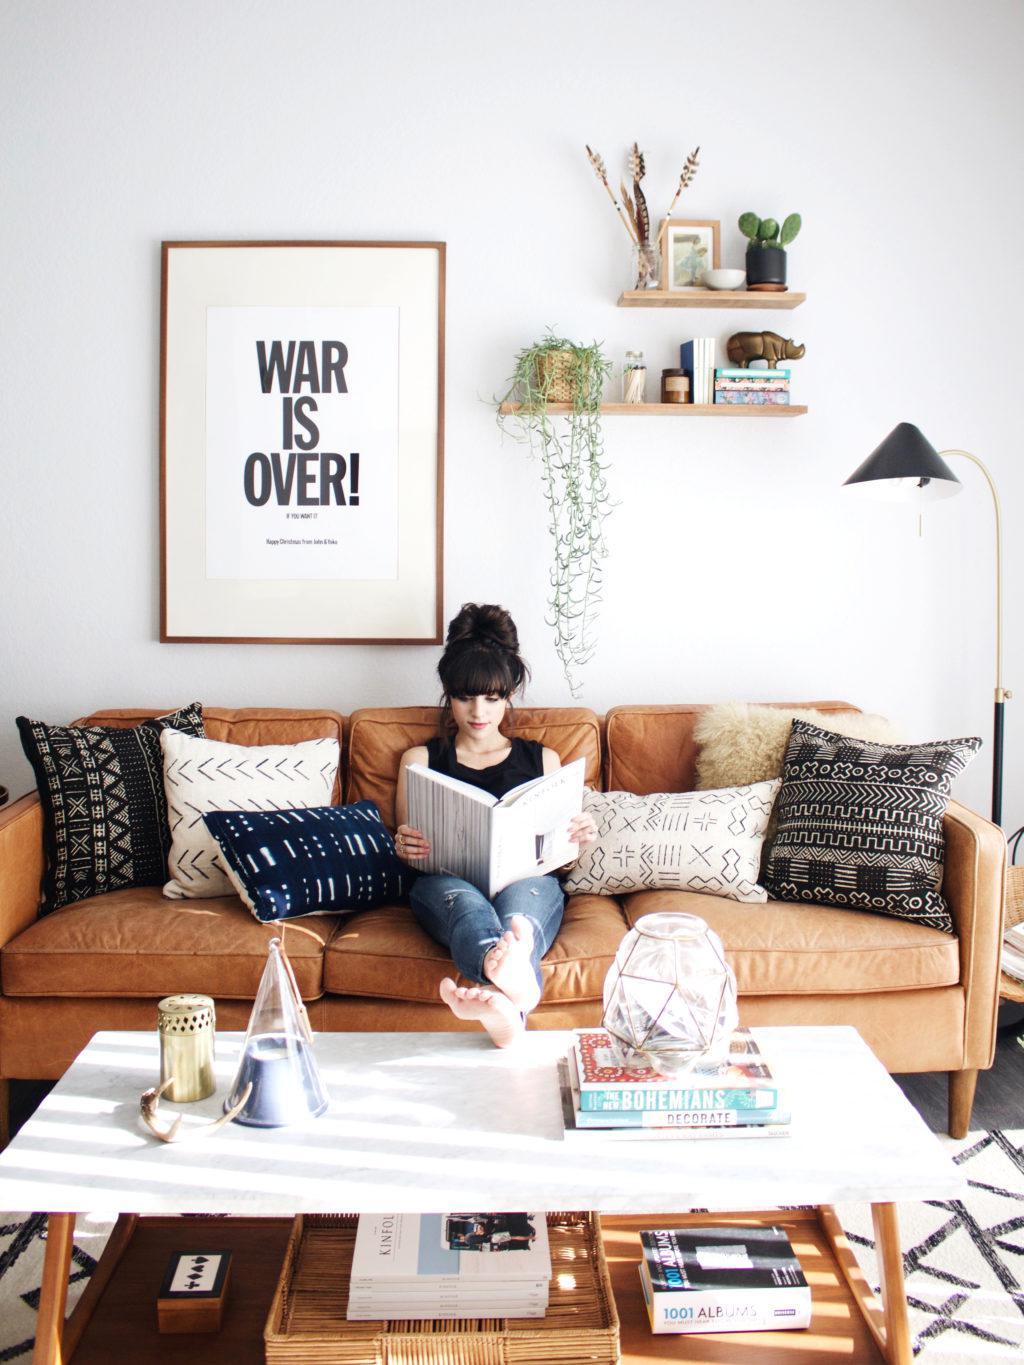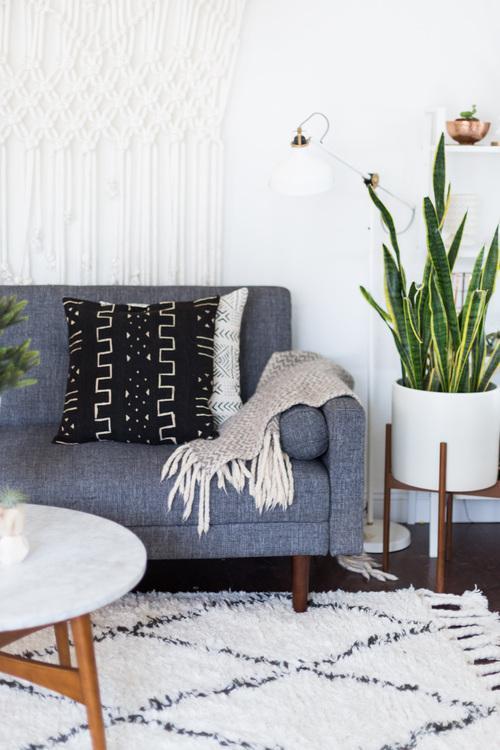The first image is the image on the left, the second image is the image on the right. Assess this claim about the two images: "An image contains a person sitting on a couch.". Correct or not? Answer yes or no. Yes. The first image is the image on the left, the second image is the image on the right. Assess this claim about the two images: "There is a person sitting on a couch.". Correct or not? Answer yes or no. Yes. 